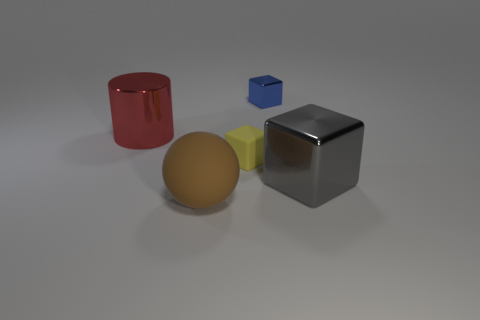What is the material of the big object that is on the right side of the blue metallic block?
Offer a very short reply. Metal. There is a large red cylinder; are there any things behind it?
Provide a short and direct response. Yes. Does the brown rubber ball have the same size as the yellow object?
Make the answer very short. No. How many big balls have the same material as the big red thing?
Provide a short and direct response. 0. What is the size of the shiny cube behind the large cylinder on the left side of the brown thing?
Provide a short and direct response. Small. What color is the object that is behind the brown rubber object and in front of the small yellow object?
Give a very brief answer. Gray. Do the large red object and the yellow object have the same shape?
Provide a short and direct response. No. What is the shape of the object behind the metal object left of the large brown ball?
Offer a very short reply. Cube. There is a blue metal thing; is its shape the same as the small yellow rubber object on the right side of the big red metallic object?
Make the answer very short. Yes. The metallic cube that is the same size as the red shiny object is what color?
Offer a very short reply. Gray. 